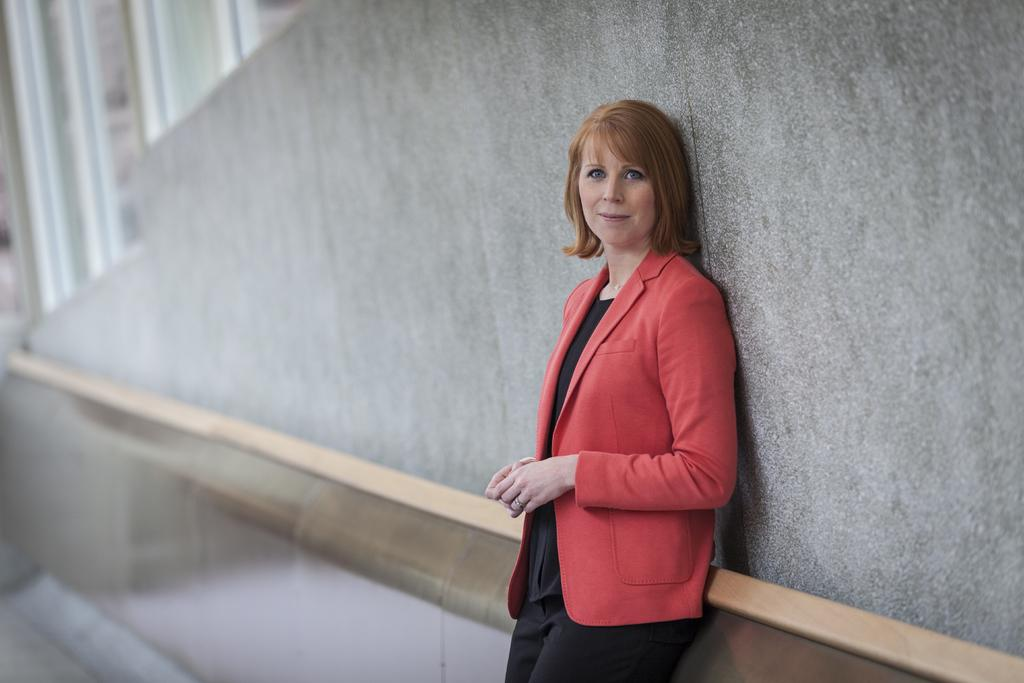What is the main subject in the image? There is a woman standing in the image. Can you describe the background of the image? There is a wall visible in the background of the image. What type of plant is the yak eating in the image? There is no yak or plant present in the image; it only features a woman standing in front of a wall. 